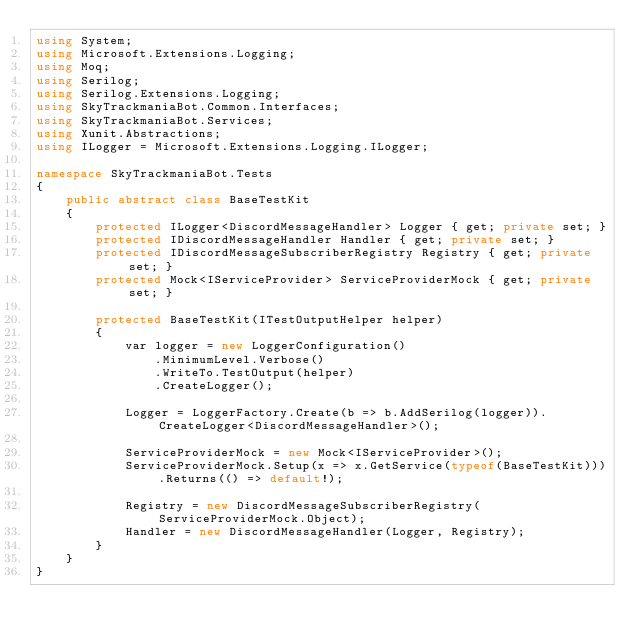Convert code to text. <code><loc_0><loc_0><loc_500><loc_500><_C#_>using System;
using Microsoft.Extensions.Logging;
using Moq;
using Serilog;
using Serilog.Extensions.Logging;
using SkyTrackmaniaBot.Common.Interfaces;
using SkyTrackmaniaBot.Services;
using Xunit.Abstractions;
using ILogger = Microsoft.Extensions.Logging.ILogger;

namespace SkyTrackmaniaBot.Tests
{
    public abstract class BaseTestKit
    {
        protected ILogger<DiscordMessageHandler> Logger { get; private set; }
        protected IDiscordMessageHandler Handler { get; private set; }
        protected IDiscordMessageSubscriberRegistry Registry { get; private set; }
        protected Mock<IServiceProvider> ServiceProviderMock { get; private set; }

        protected BaseTestKit(ITestOutputHelper helper)
        {
            var logger = new LoggerConfiguration()
                .MinimumLevel.Verbose()
                .WriteTo.TestOutput(helper)
                .CreateLogger();

            Logger = LoggerFactory.Create(b => b.AddSerilog(logger)).CreateLogger<DiscordMessageHandler>();

            ServiceProviderMock = new Mock<IServiceProvider>();
            ServiceProviderMock.Setup(x => x.GetService(typeof(BaseTestKit))).Returns(() => default!);

            Registry = new DiscordMessageSubscriberRegistry(ServiceProviderMock.Object);
            Handler = new DiscordMessageHandler(Logger, Registry);
        }
    }
}</code> 